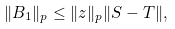<formula> <loc_0><loc_0><loc_500><loc_500>\| B _ { 1 } \| _ { p } \leq \| z \| _ { p } \| S - T \| ,</formula> 